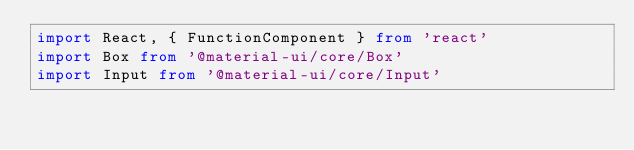Convert code to text. <code><loc_0><loc_0><loc_500><loc_500><_TypeScript_>import React, { FunctionComponent } from 'react'
import Box from '@material-ui/core/Box'
import Input from '@material-ui/core/Input'</code> 